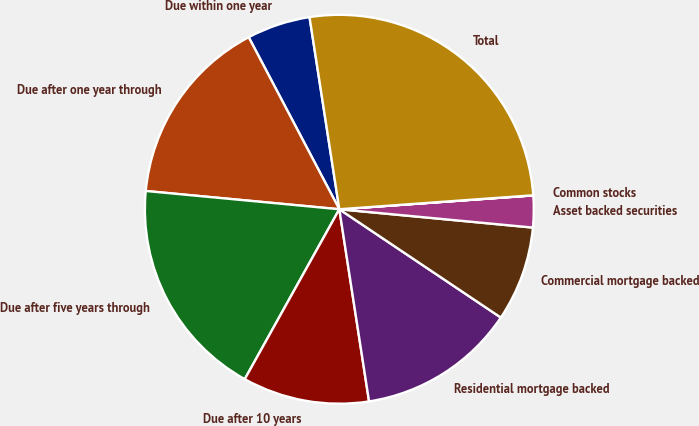Convert chart to OTSL. <chart><loc_0><loc_0><loc_500><loc_500><pie_chart><fcel>Due within one year<fcel>Due after one year through<fcel>Due after five years through<fcel>Due after 10 years<fcel>Residential mortgage backed<fcel>Commercial mortgage backed<fcel>Asset backed securities<fcel>Common stocks<fcel>Total<nl><fcel>5.27%<fcel>15.79%<fcel>18.42%<fcel>10.53%<fcel>13.16%<fcel>7.9%<fcel>2.64%<fcel>0.01%<fcel>26.31%<nl></chart> 